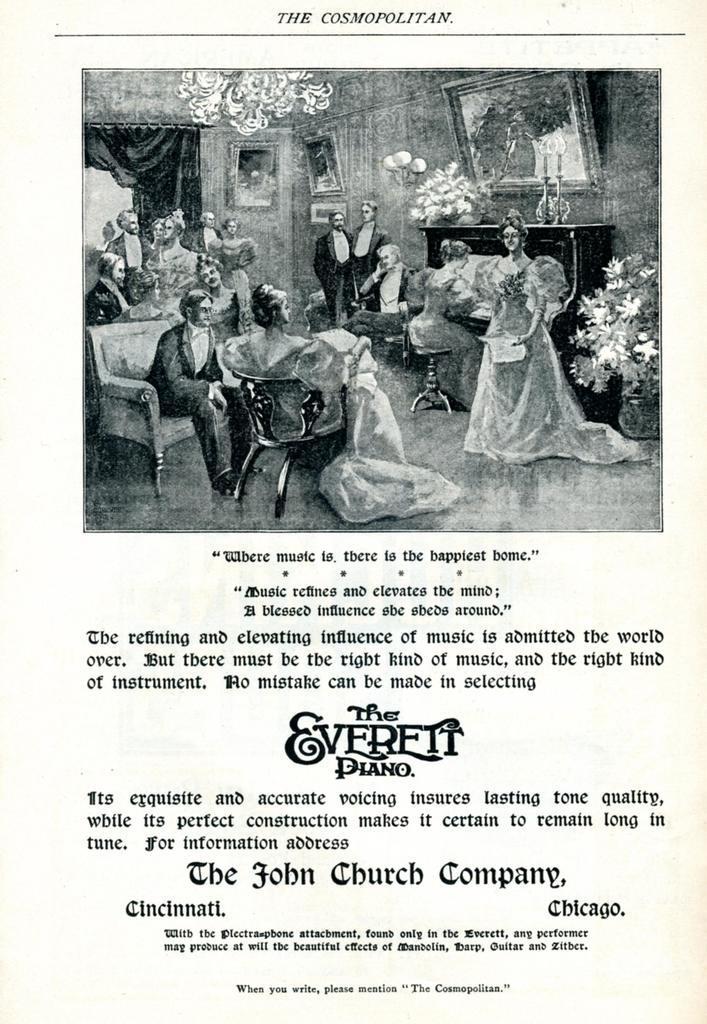Can you describe this image briefly? In this image, there is a page contains a photograph and some text. 